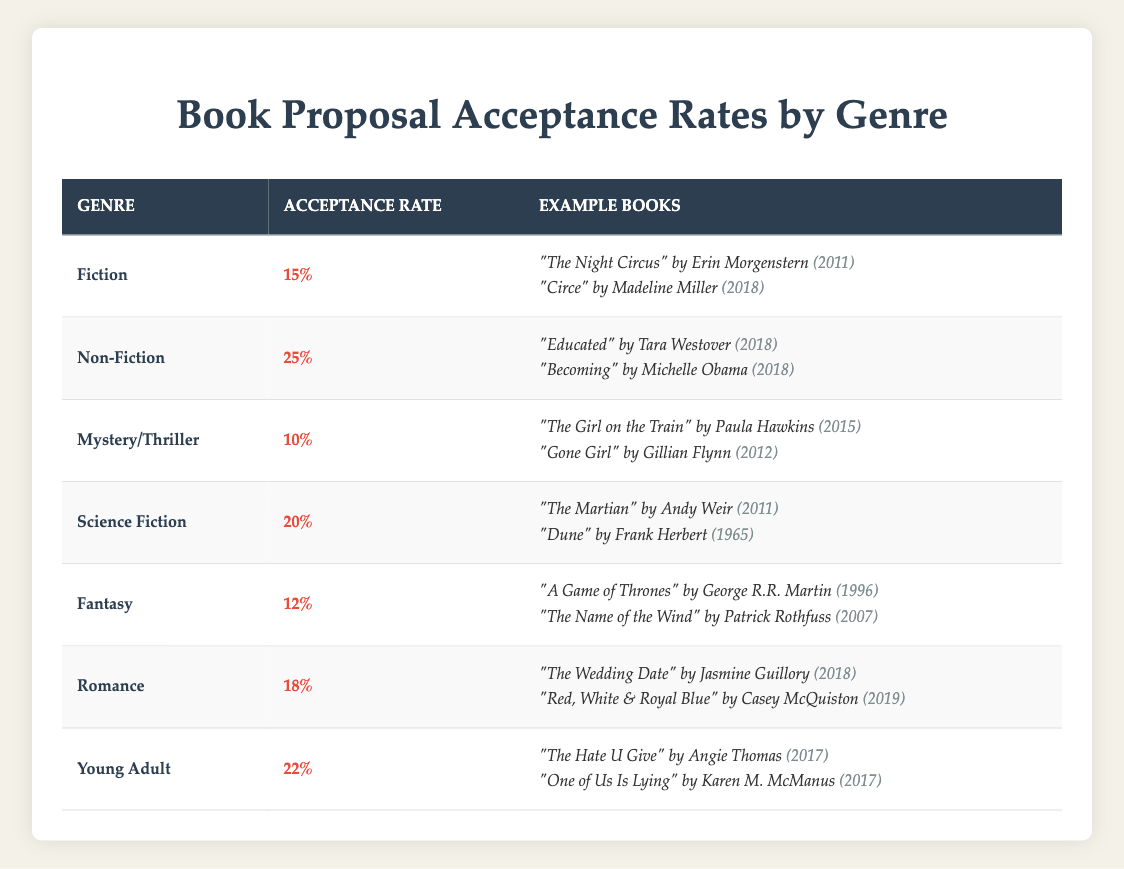What is the acceptance rate for Non-Fiction genres? According to the table, the acceptance rate for Non-Fiction is listed as 25%.
Answer: 25% Which genre has the highest acceptance rate? The Non-Fiction genre has the highest acceptance rate at 25%, compared to others like Young Adult at 22% and Fiction at 15%.
Answer: Non-Fiction Calculate the average acceptance rate of Mystery/Thriller and Fantasy genres. The acceptance rate for Mystery/Thriller is 10% and for Fantasy is 12%. Adding these rates gives 10 + 12 = 22, then averaging by dividing by 2 results in 22/2 = 11%.
Answer: 11% Is the acceptance rate for Science Fiction higher than that of Romance? The acceptance rate for Science Fiction is 20%, while Romance has an acceptance rate of 18%. Since 20% is more than 18%, the statement is true.
Answer: Yes What is the total acceptance rate for all listed genres? The total acceptance rate is the sum of all acceptance rates: 15 + 25 + 10 + 20 + 12 + 18 + 22 = 132%. To find the average, we divide by the number of genres (7) which gives 132/7 = 18.86%.
Answer: 18.86% How many example books are listed for the Fiction genre? There are two example books provided for the Fiction genre: "The Night Circus" and "Circe".
Answer: 2 Does the acceptance rate indicate that Young Adult books are more likely to be accepted than Mystery/Thriller books? The acceptance rate for Young Adult is 22%, while for Mystery/Thriller it is 10%. Since 22% is greater than 10%, this indicates that Young Adult books are more likely to be accepted.
Answer: Yes What percentage difference exists between the acceptance rates of Non-Fiction and Science Fiction genres? The acceptance rate for Non-Fiction is 25% and for Science Fiction is 20%. The difference is 25 - 20 = 5%. To find the percentage difference relative to Non-Fiction, we calculate (5/25)*100 = 20%.
Answer: 20% Identify the year of the most recent example book in the Romance genre. The example book "Red, White & Royal Blue" from the Romance genre was published in 2019, which is the most recent.
Answer: 2019 Are there any genres that have lower acceptance rates than Fantasy? Fantasy has an acceptance rate of 12%. The genres with lower rates are Mystery/Thriller at 10% and Fiction at 15%. Therefore, both of these genres have lower acceptance rates.
Answer: Yes 